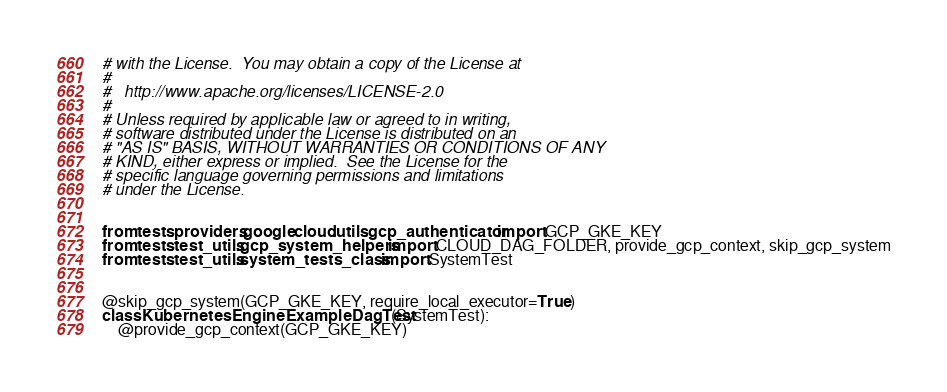Convert code to text. <code><loc_0><loc_0><loc_500><loc_500><_Python_># with the License.  You may obtain a copy of the License at
#
#   http://www.apache.org/licenses/LICENSE-2.0
#
# Unless required by applicable law or agreed to in writing,
# software distributed under the License is distributed on an
# "AS IS" BASIS, WITHOUT WARRANTIES OR CONDITIONS OF ANY
# KIND, either express or implied.  See the License for the
# specific language governing permissions and limitations
# under the License.


from tests.providers.google.cloud.utils.gcp_authenticator import GCP_GKE_KEY
from tests.test_utils.gcp_system_helpers import CLOUD_DAG_FOLDER, provide_gcp_context, skip_gcp_system
from tests.test_utils.system_tests_class import SystemTest


@skip_gcp_system(GCP_GKE_KEY, require_local_executor=True)
class KubernetesEngineExampleDagTest(SystemTest):
    @provide_gcp_context(GCP_GKE_KEY)</code> 